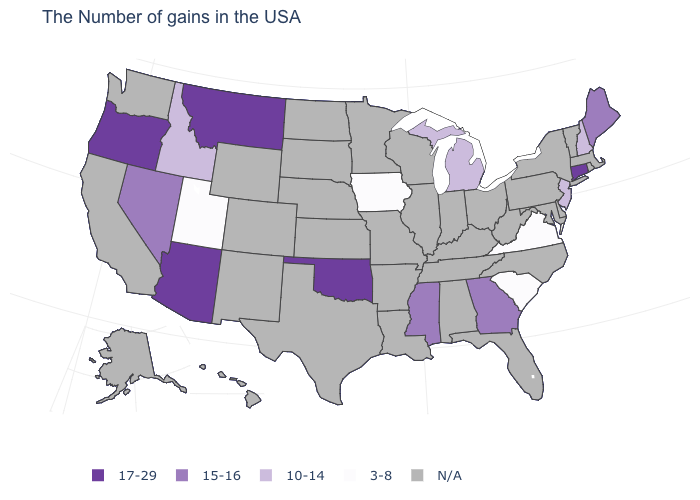What is the highest value in the USA?
Concise answer only. 17-29. Is the legend a continuous bar?
Short answer required. No. What is the value of Massachusetts?
Concise answer only. N/A. Which states have the highest value in the USA?
Give a very brief answer. Connecticut, Oklahoma, Montana, Arizona, Oregon. Name the states that have a value in the range 10-14?
Write a very short answer. New Hampshire, New Jersey, Michigan, Idaho. What is the value of New Jersey?
Short answer required. 10-14. Name the states that have a value in the range 17-29?
Answer briefly. Connecticut, Oklahoma, Montana, Arizona, Oregon. Does the first symbol in the legend represent the smallest category?
Quick response, please. No. What is the highest value in states that border Idaho?
Answer briefly. 17-29. Name the states that have a value in the range 15-16?
Short answer required. Maine, Georgia, Mississippi, Nevada. Name the states that have a value in the range 17-29?
Write a very short answer. Connecticut, Oklahoma, Montana, Arizona, Oregon. Is the legend a continuous bar?
Quick response, please. No. Does the first symbol in the legend represent the smallest category?
Answer briefly. No. 